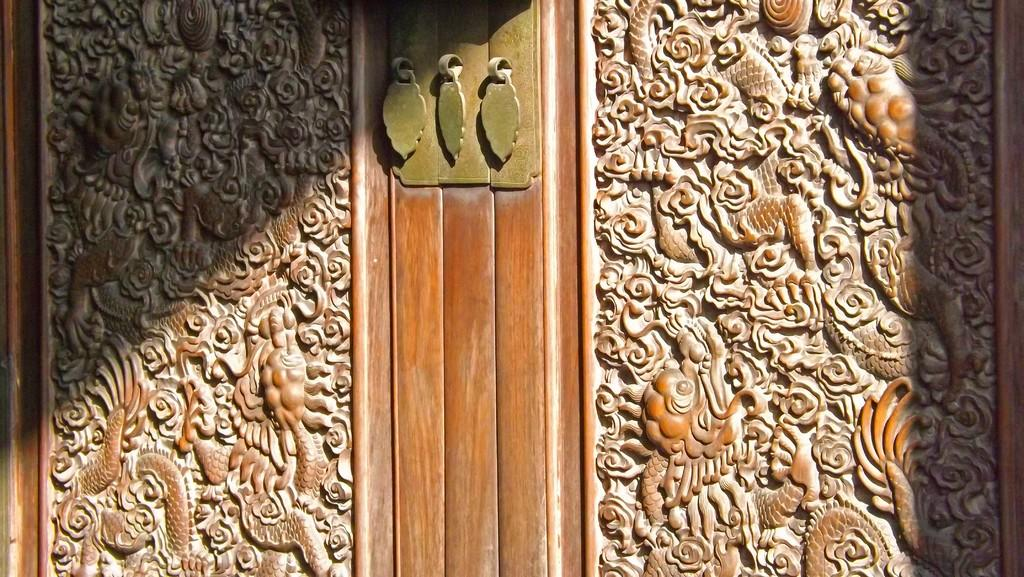What type of material is used to construct the wall in the image? The wall in the image is made of wood. Is there anything attached to the wooden wall? Yes, there is a metal object attached to the wooden wall. What decorative elements can be seen on the wooden wall? There are sculptures on the wooden wall. Can you see any fangs on the wooden wall in the image? There are no fangs present on the wooden wall in the image. How many fingers are visible on the wooden wall in the image? There are no fingers visible on the wooden wall in the image. 